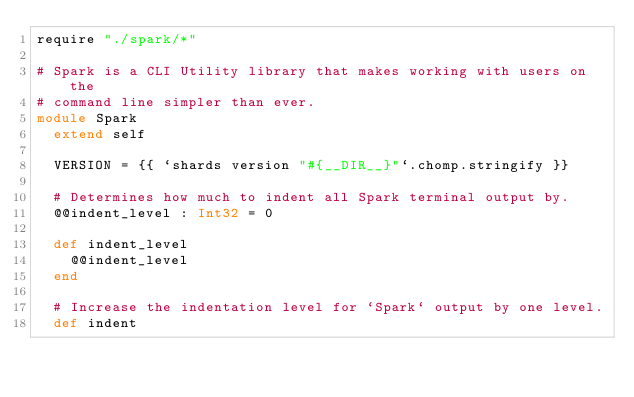<code> <loc_0><loc_0><loc_500><loc_500><_Crystal_>require "./spark/*"

# Spark is a CLI Utility library that makes working with users on the
# command line simpler than ever.
module Spark
  extend self

  VERSION = {{ `shards version "#{__DIR__}"`.chomp.stringify }}

  # Determines how much to indent all Spark terminal output by.
  @@indent_level : Int32 = 0

  def indent_level
    @@indent_level
  end

  # Increase the indentation level for `Spark` output by one level.
  def indent</code> 